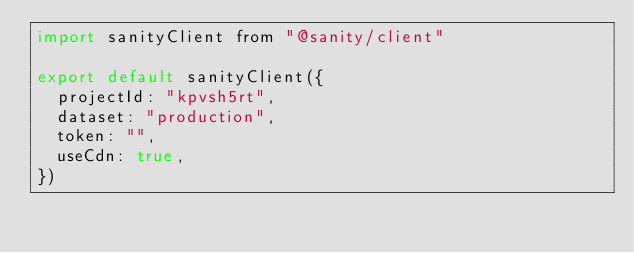<code> <loc_0><loc_0><loc_500><loc_500><_JavaScript_>import sanityClient from "@sanity/client"

export default sanityClient({
  projectId: "kpvsh5rt",
  dataset: "production",
  token: "",
  useCdn: true,
})
</code> 